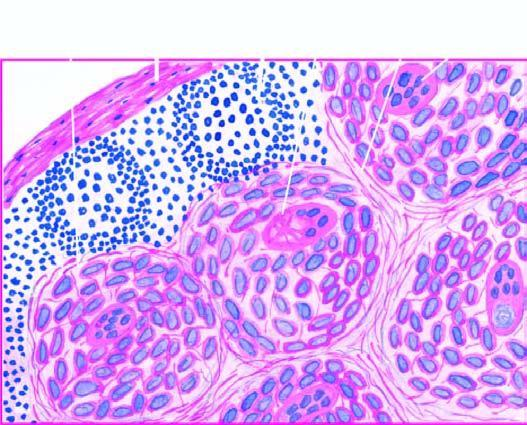what have paucity of lymphocytes?
Answer the question using a single word or phrase. Non-caseating epithelioid cell granulomas 